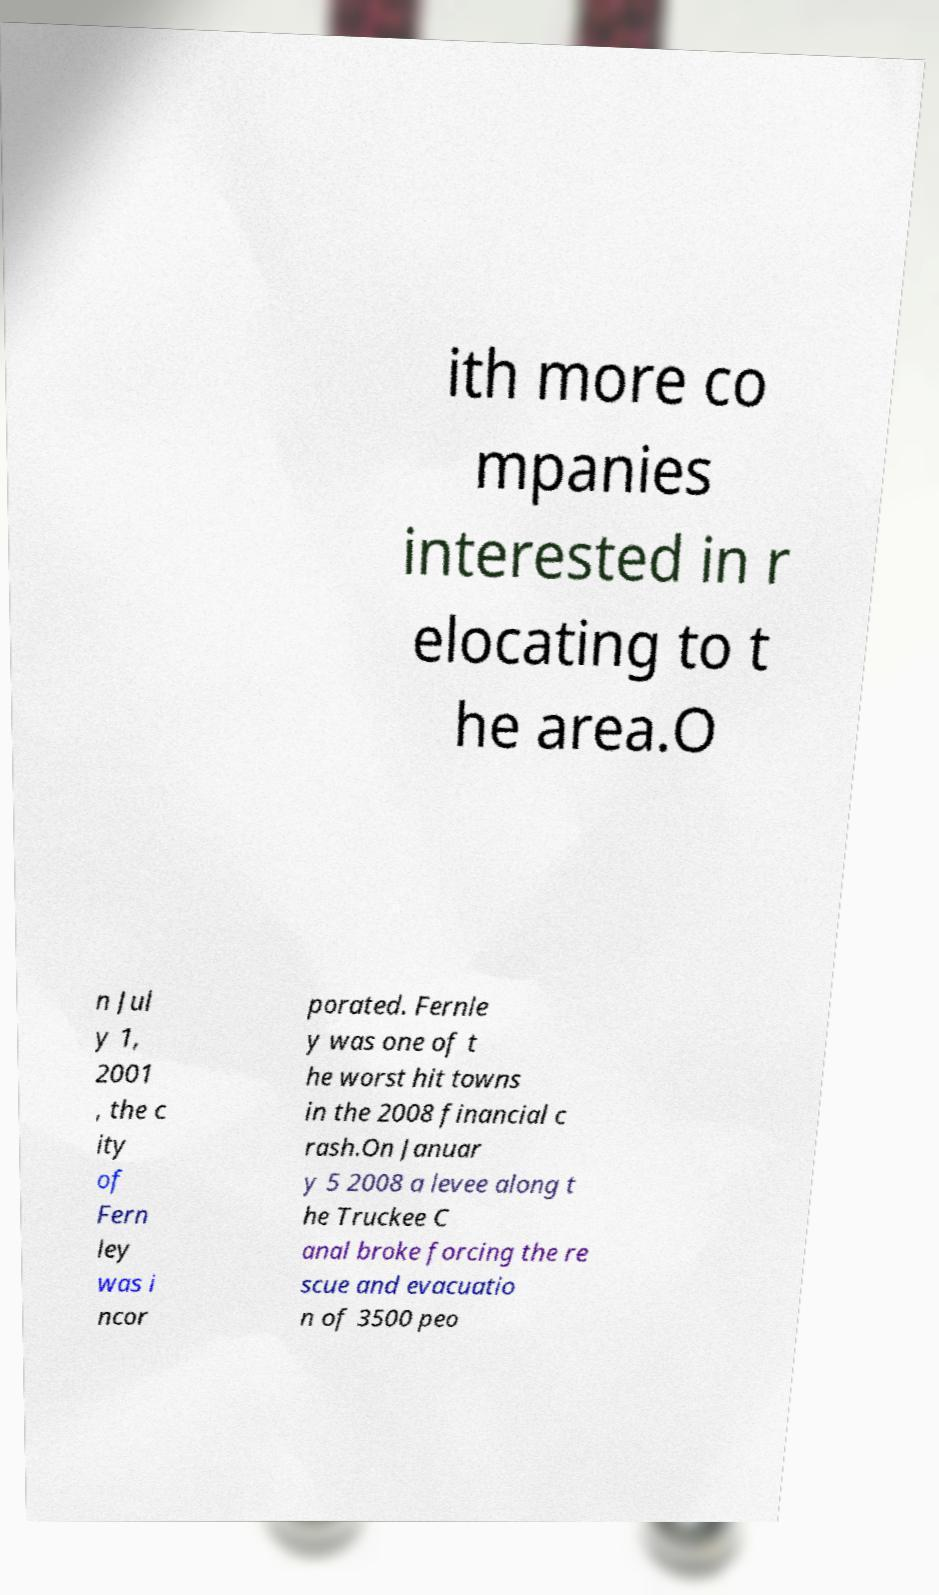Please read and relay the text visible in this image. What does it say? ith more co mpanies interested in r elocating to t he area.O n Jul y 1, 2001 , the c ity of Fern ley was i ncor porated. Fernle y was one of t he worst hit towns in the 2008 financial c rash.On Januar y 5 2008 a levee along t he Truckee C anal broke forcing the re scue and evacuatio n of 3500 peo 